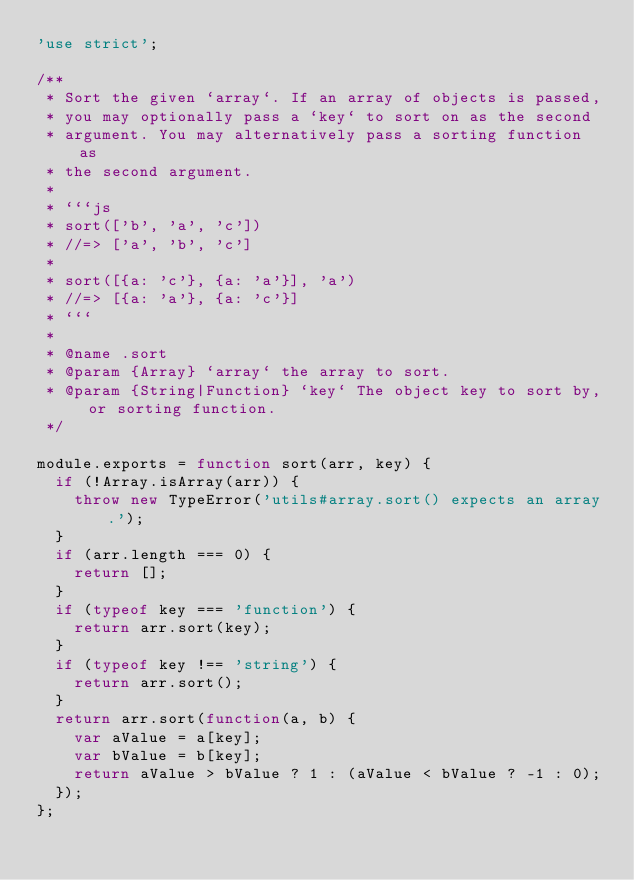<code> <loc_0><loc_0><loc_500><loc_500><_JavaScript_>'use strict';

/**
 * Sort the given `array`. If an array of objects is passed,
 * you may optionally pass a `key` to sort on as the second
 * argument. You may alternatively pass a sorting function as
 * the second argument.
 *
 * ```js
 * sort(['b', 'a', 'c'])
 * //=> ['a', 'b', 'c']
 *
 * sort([{a: 'c'}, {a: 'a'}], 'a')
 * //=> [{a: 'a'}, {a: 'c'}]
 * ```
 *
 * @name .sort
 * @param {Array} `array` the array to sort.
 * @param {String|Function} `key` The object key to sort by, or sorting function.
 */

module.exports = function sort(arr, key) {
  if (!Array.isArray(arr)) {
    throw new TypeError('utils#array.sort() expects an array.');
  }
  if (arr.length === 0) {
    return [];
  }
  if (typeof key === 'function') {
    return arr.sort(key);
  }
  if (typeof key !== 'string') {
    return arr.sort();
  }
  return arr.sort(function(a, b) {
    var aValue = a[key];
    var bValue = b[key];
    return aValue > bValue ? 1 : (aValue < bValue ? -1 : 0);
  });
};
</code> 